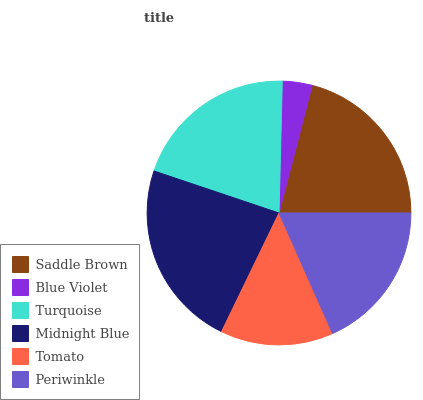Is Blue Violet the minimum?
Answer yes or no. Yes. Is Midnight Blue the maximum?
Answer yes or no. Yes. Is Turquoise the minimum?
Answer yes or no. No. Is Turquoise the maximum?
Answer yes or no. No. Is Turquoise greater than Blue Violet?
Answer yes or no. Yes. Is Blue Violet less than Turquoise?
Answer yes or no. Yes. Is Blue Violet greater than Turquoise?
Answer yes or no. No. Is Turquoise less than Blue Violet?
Answer yes or no. No. Is Turquoise the high median?
Answer yes or no. Yes. Is Periwinkle the low median?
Answer yes or no. Yes. Is Periwinkle the high median?
Answer yes or no. No. Is Turquoise the low median?
Answer yes or no. No. 